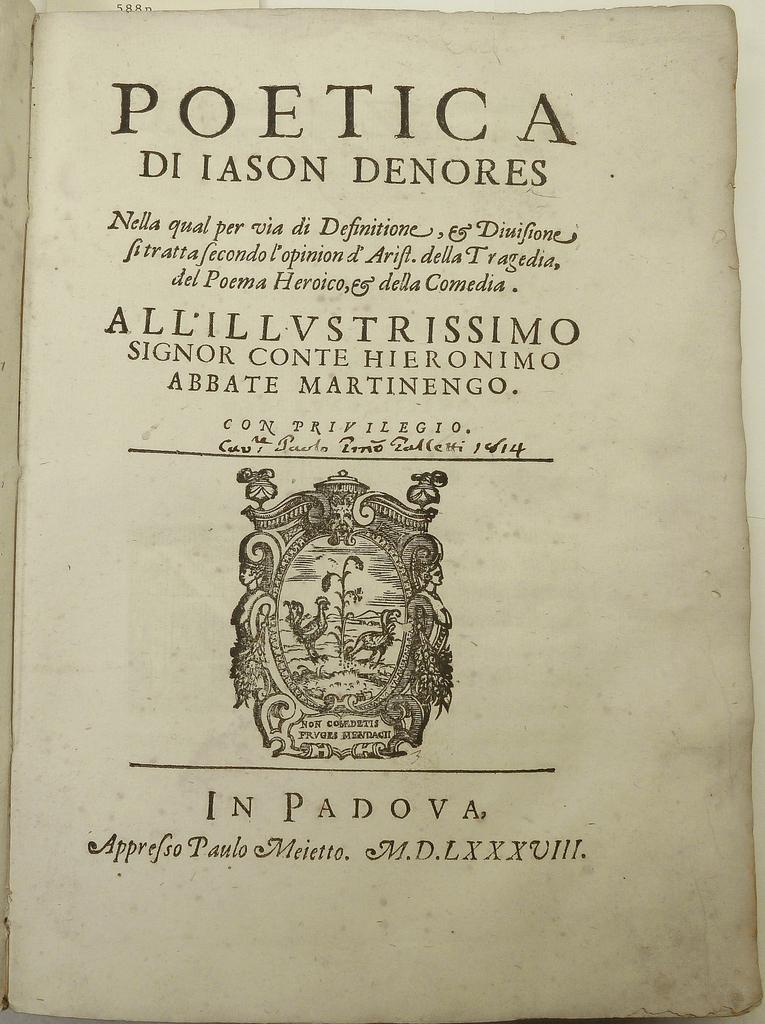What is the title of the book?
Make the answer very short. Poetica. Who wrote this book?
Ensure brevity in your answer.  Paulo meietto. 